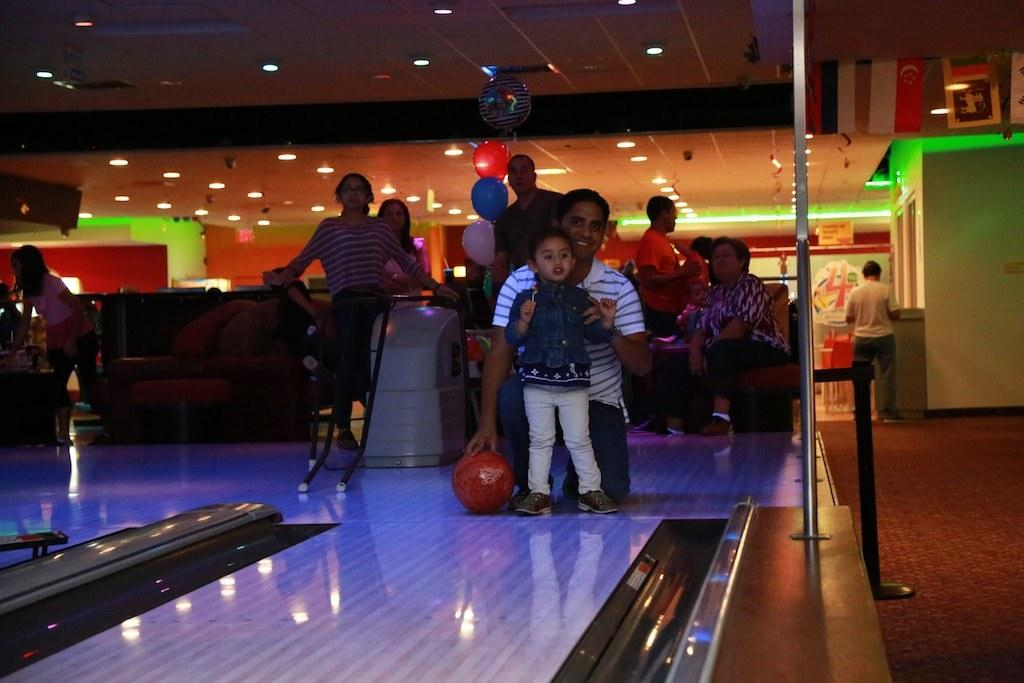How many people are in the group visible in the image? There is a group of people in the image, but the exact number cannot be determined without more specific information. What is located behind the group of people in the image? There is a wall in the image. What type of illumination is present in the image? There are lights in the image. What object is visible in the image that is typically used for playing games? There is a ball in the image. What type of stone is being used to build the wing in the image? There is no stone or wing present in the image. How does the snow affect the visibility of the people in the image? There is no snow present in the image, so it does not affect the visibility of the people. 